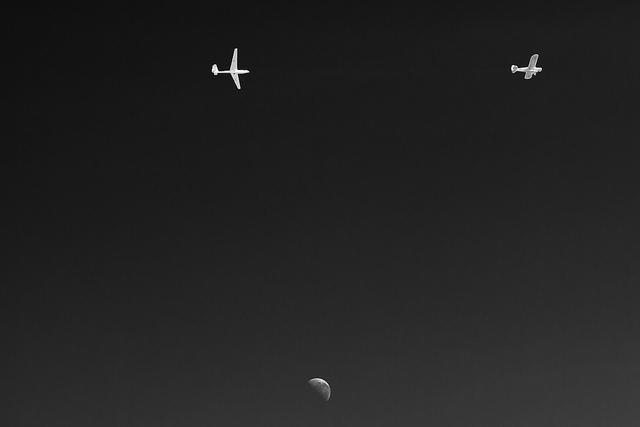How many airplanes are there?
Give a very brief answer. 2. How many people are standing on a white line?
Give a very brief answer. 0. 